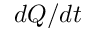<formula> <loc_0><loc_0><loc_500><loc_500>d Q / d t</formula> 